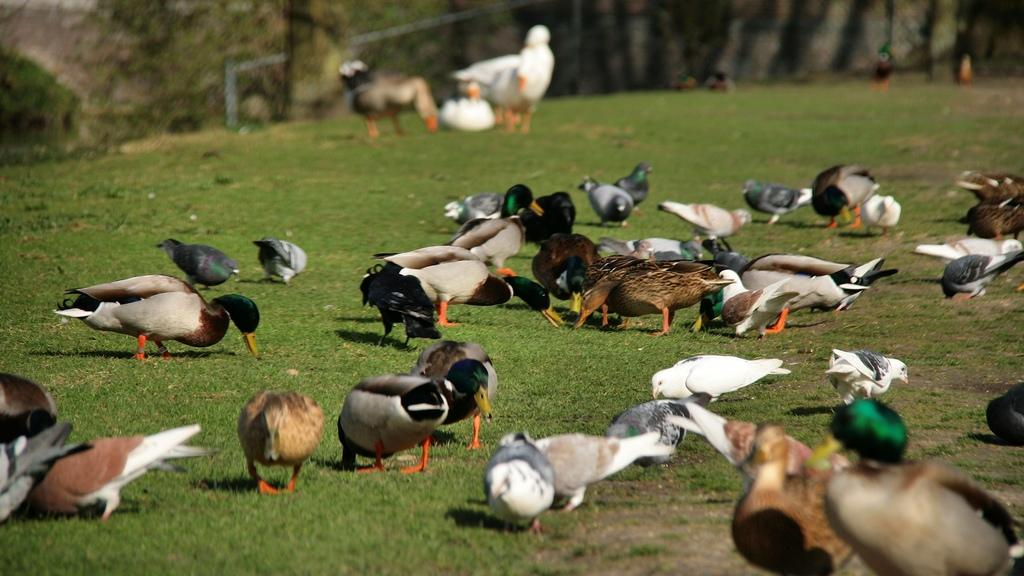What type of animals are present in the image? There is a group of birds in the image. What is the birds standing on? The birds are on green grass. Can you describe any other natural elements in the image? There appears to be a tree trunk on the top left side of the image. What is the name of the governor who is overseeing the operation in the image? There is no governor or operation present in the image; it features a group of birds on green grass with a tree trunk in the background. 